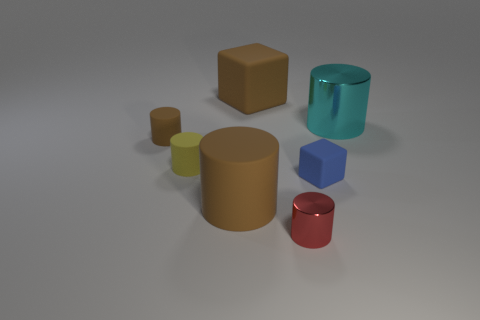The small metal object has what color?
Provide a succinct answer. Red. How many things are shiny objects left of the cyan metallic cylinder or large cyan objects?
Give a very brief answer. 2. There is a brown thing that is in front of the small brown cylinder; does it have the same size as the matte object on the right side of the big brown matte cube?
Provide a succinct answer. No. Is there any other thing that is the same material as the big cube?
Your response must be concise. Yes. How many objects are either brown things behind the small brown rubber cylinder or cylinders that are to the right of the big brown rubber cube?
Offer a very short reply. 3. Do the tiny blue block and the brown cylinder that is in front of the small yellow thing have the same material?
Your answer should be compact. Yes. There is a object that is behind the yellow rubber cylinder and on the left side of the big brown cylinder; what shape is it?
Your response must be concise. Cylinder. What number of other objects are there of the same color as the big matte cylinder?
Offer a terse response. 2. The blue object has what shape?
Your response must be concise. Cube. What color is the large rubber thing that is behind the tiny thing on the right side of the red shiny cylinder?
Your answer should be compact. Brown. 